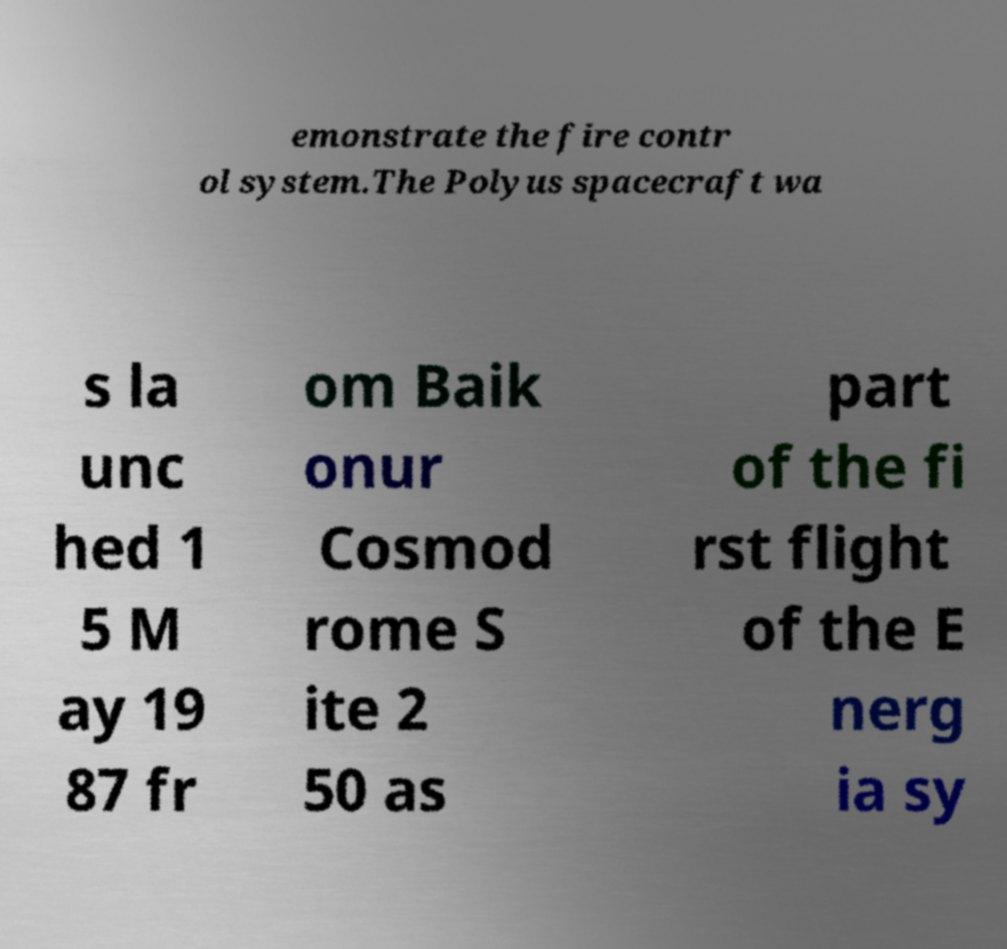For documentation purposes, I need the text within this image transcribed. Could you provide that? emonstrate the fire contr ol system.The Polyus spacecraft wa s la unc hed 1 5 M ay 19 87 fr om Baik onur Cosmod rome S ite 2 50 as part of the fi rst flight of the E nerg ia sy 